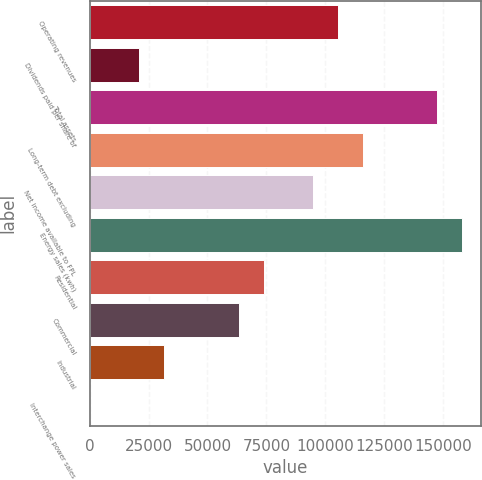Convert chart to OTSL. <chart><loc_0><loc_0><loc_500><loc_500><bar_chart><fcel>Operating revenues<fcel>Dividends paid per share of<fcel>Total assets<fcel>Long-term debt excluding<fcel>Net income available to FPL<fcel>Energy sales (kwh)<fcel>Residential<fcel>Commercial<fcel>Industrial<fcel>Interchange power sales<nl><fcel>105414<fcel>21083.9<fcel>147579<fcel>115955<fcel>94872.7<fcel>158120<fcel>73790.2<fcel>63249<fcel>31625.2<fcel>1.4<nl></chart> 